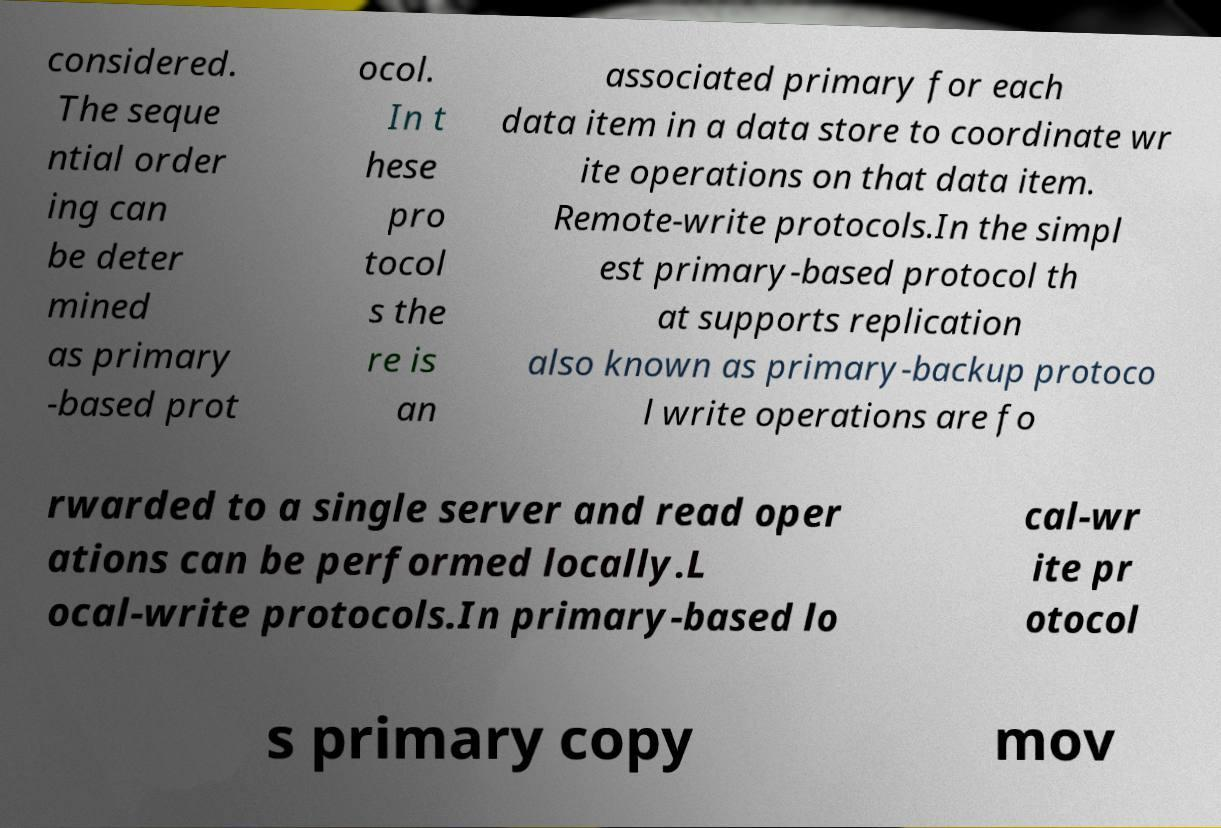For documentation purposes, I need the text within this image transcribed. Could you provide that? considered. The seque ntial order ing can be deter mined as primary -based prot ocol. In t hese pro tocol s the re is an associated primary for each data item in a data store to coordinate wr ite operations on that data item. Remote-write protocols.In the simpl est primary-based protocol th at supports replication also known as primary-backup protoco l write operations are fo rwarded to a single server and read oper ations can be performed locally.L ocal-write protocols.In primary-based lo cal-wr ite pr otocol s primary copy mov 